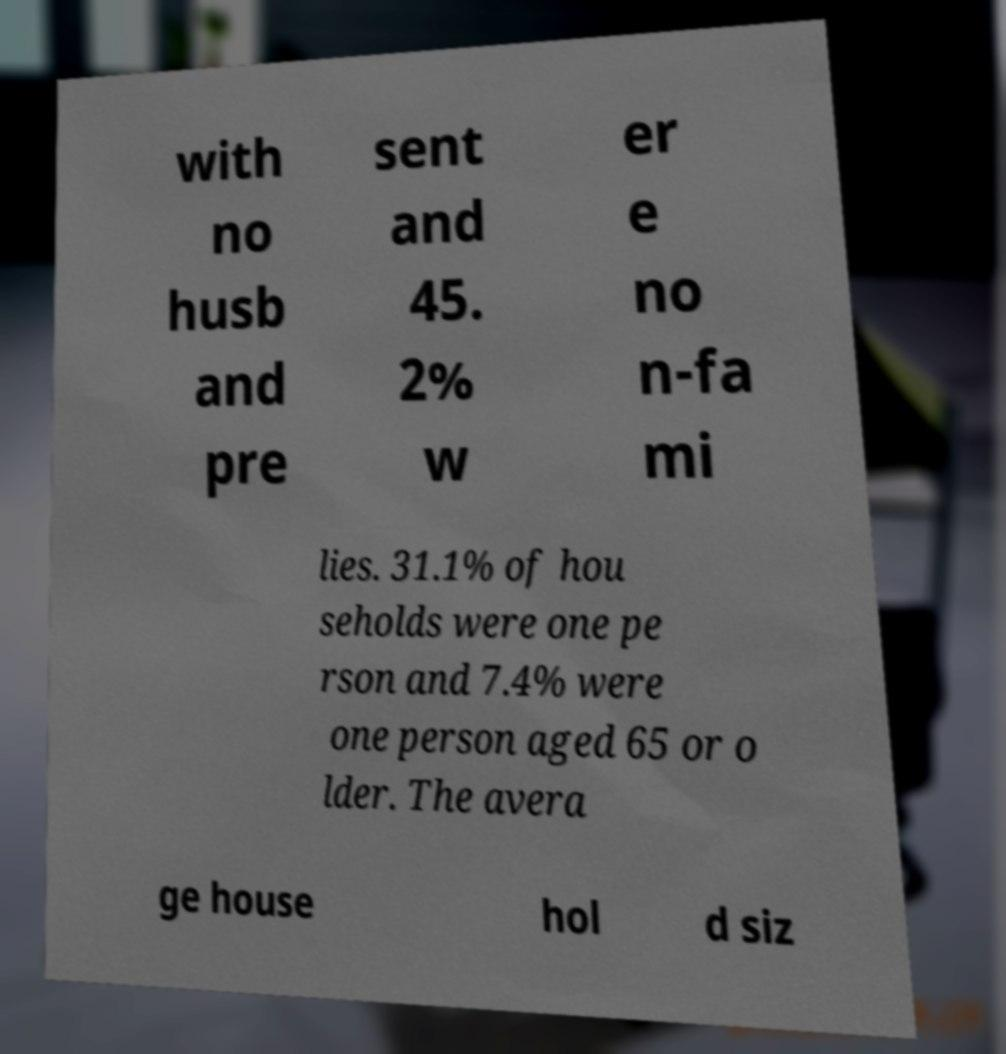What messages or text are displayed in this image? I need them in a readable, typed format. with no husb and pre sent and 45. 2% w er e no n-fa mi lies. 31.1% of hou seholds were one pe rson and 7.4% were one person aged 65 or o lder. The avera ge house hol d siz 